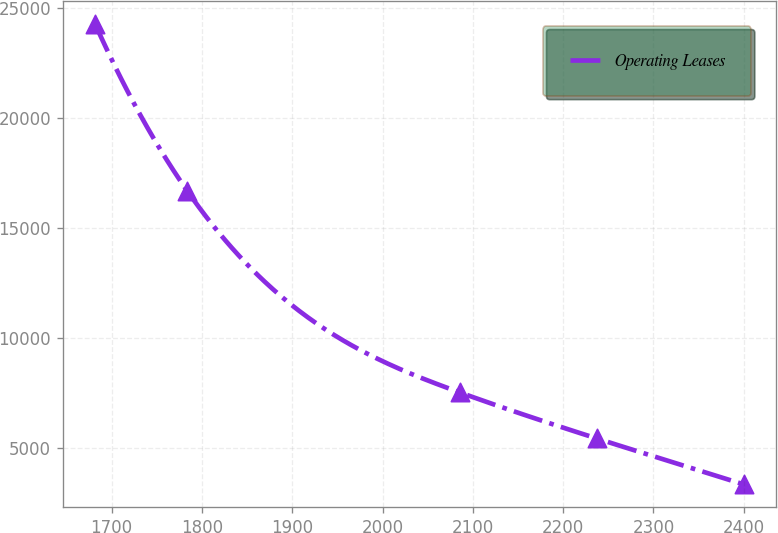Convert chart to OTSL. <chart><loc_0><loc_0><loc_500><loc_500><line_chart><ecel><fcel>Operating Leases<nl><fcel>1681.76<fcel>24261.9<nl><fcel>1783.62<fcel>16690.7<nl><fcel>2085.57<fcel>7527.27<nl><fcel>2237.17<fcel>5435.44<nl><fcel>2400.32<fcel>3343.61<nl></chart> 